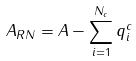<formula> <loc_0><loc_0><loc_500><loc_500>A _ { R N } = A - \sum _ { i = 1 } ^ { N _ { c } } q ^ { c } _ { i }</formula> 